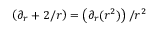Convert formula to latex. <formula><loc_0><loc_0><loc_500><loc_500>\left ( \partial _ { r } + { 2 } / { r } \right ) = \left ( \partial _ { r } ( r ^ { 2 } ) \right ) / r ^ { 2 }</formula> 